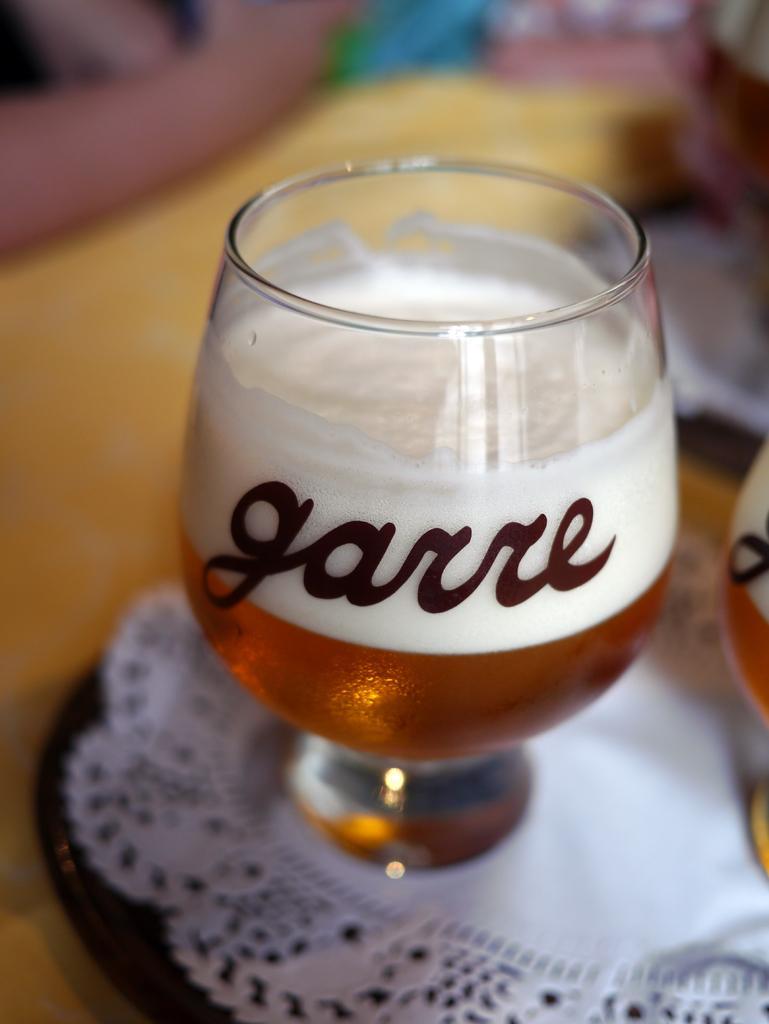Please provide a concise description of this image. In this image there are glasses with wine in it which is placed on the plate. Beside the plate there are a few other objects. 